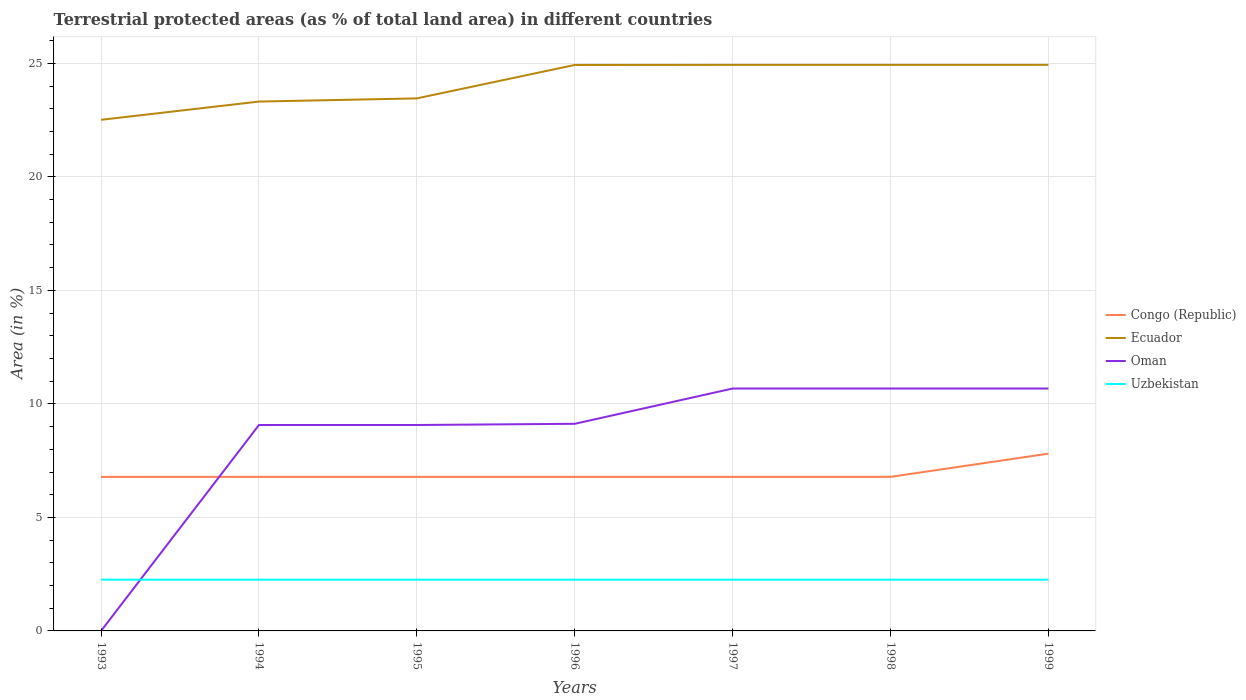How many different coloured lines are there?
Keep it short and to the point. 4. Is the number of lines equal to the number of legend labels?
Keep it short and to the point. Yes. Across all years, what is the maximum percentage of terrestrial protected land in Oman?
Provide a succinct answer. 0. What is the difference between the highest and the second highest percentage of terrestrial protected land in Oman?
Your answer should be very brief. 10.68. What is the difference between the highest and the lowest percentage of terrestrial protected land in Uzbekistan?
Keep it short and to the point. 7. Does the graph contain any zero values?
Offer a terse response. No. How many legend labels are there?
Offer a terse response. 4. What is the title of the graph?
Give a very brief answer. Terrestrial protected areas (as % of total land area) in different countries. What is the label or title of the Y-axis?
Provide a short and direct response. Area (in %). What is the Area (in %) in Congo (Republic) in 1993?
Your answer should be very brief. 6.79. What is the Area (in %) of Ecuador in 1993?
Your answer should be compact. 22.51. What is the Area (in %) of Oman in 1993?
Offer a very short reply. 0. What is the Area (in %) in Uzbekistan in 1993?
Offer a terse response. 2.26. What is the Area (in %) of Congo (Republic) in 1994?
Give a very brief answer. 6.79. What is the Area (in %) of Ecuador in 1994?
Provide a succinct answer. 23.32. What is the Area (in %) of Oman in 1994?
Provide a succinct answer. 9.07. What is the Area (in %) in Uzbekistan in 1994?
Offer a terse response. 2.26. What is the Area (in %) of Congo (Republic) in 1995?
Offer a terse response. 6.79. What is the Area (in %) of Ecuador in 1995?
Provide a succinct answer. 23.46. What is the Area (in %) in Oman in 1995?
Provide a short and direct response. 9.07. What is the Area (in %) in Uzbekistan in 1995?
Your response must be concise. 2.26. What is the Area (in %) of Congo (Republic) in 1996?
Ensure brevity in your answer.  6.79. What is the Area (in %) in Ecuador in 1996?
Your answer should be compact. 24.93. What is the Area (in %) in Oman in 1996?
Provide a short and direct response. 9.12. What is the Area (in %) of Uzbekistan in 1996?
Your response must be concise. 2.26. What is the Area (in %) in Congo (Republic) in 1997?
Offer a terse response. 6.79. What is the Area (in %) in Ecuador in 1997?
Provide a short and direct response. 24.93. What is the Area (in %) in Oman in 1997?
Provide a short and direct response. 10.68. What is the Area (in %) of Uzbekistan in 1997?
Your response must be concise. 2.26. What is the Area (in %) of Congo (Republic) in 1998?
Provide a succinct answer. 6.79. What is the Area (in %) in Ecuador in 1998?
Your answer should be very brief. 24.93. What is the Area (in %) in Oman in 1998?
Make the answer very short. 10.68. What is the Area (in %) of Uzbekistan in 1998?
Your response must be concise. 2.26. What is the Area (in %) in Congo (Republic) in 1999?
Make the answer very short. 7.81. What is the Area (in %) in Ecuador in 1999?
Ensure brevity in your answer.  24.93. What is the Area (in %) of Oman in 1999?
Make the answer very short. 10.68. What is the Area (in %) of Uzbekistan in 1999?
Make the answer very short. 2.26. Across all years, what is the maximum Area (in %) of Congo (Republic)?
Make the answer very short. 7.81. Across all years, what is the maximum Area (in %) in Ecuador?
Offer a very short reply. 24.93. Across all years, what is the maximum Area (in %) of Oman?
Provide a short and direct response. 10.68. Across all years, what is the maximum Area (in %) in Uzbekistan?
Ensure brevity in your answer.  2.26. Across all years, what is the minimum Area (in %) in Congo (Republic)?
Offer a terse response. 6.79. Across all years, what is the minimum Area (in %) of Ecuador?
Offer a very short reply. 22.51. Across all years, what is the minimum Area (in %) in Oman?
Your response must be concise. 0. Across all years, what is the minimum Area (in %) of Uzbekistan?
Provide a short and direct response. 2.26. What is the total Area (in %) of Congo (Republic) in the graph?
Your response must be concise. 48.53. What is the total Area (in %) in Ecuador in the graph?
Provide a short and direct response. 169.02. What is the total Area (in %) of Oman in the graph?
Your response must be concise. 59.3. What is the total Area (in %) in Uzbekistan in the graph?
Your response must be concise. 15.8. What is the difference between the Area (in %) of Congo (Republic) in 1993 and that in 1994?
Provide a short and direct response. -0. What is the difference between the Area (in %) of Ecuador in 1993 and that in 1994?
Provide a short and direct response. -0.8. What is the difference between the Area (in %) of Oman in 1993 and that in 1994?
Offer a very short reply. -9.07. What is the difference between the Area (in %) of Uzbekistan in 1993 and that in 1994?
Provide a succinct answer. 0. What is the difference between the Area (in %) of Congo (Republic) in 1993 and that in 1995?
Provide a succinct answer. -0. What is the difference between the Area (in %) in Ecuador in 1993 and that in 1995?
Provide a short and direct response. -0.94. What is the difference between the Area (in %) of Oman in 1993 and that in 1995?
Provide a succinct answer. -9.07. What is the difference between the Area (in %) of Congo (Republic) in 1993 and that in 1996?
Make the answer very short. -0. What is the difference between the Area (in %) of Ecuador in 1993 and that in 1996?
Provide a succinct answer. -2.42. What is the difference between the Area (in %) in Oman in 1993 and that in 1996?
Your answer should be very brief. -9.12. What is the difference between the Area (in %) of Uzbekistan in 1993 and that in 1996?
Ensure brevity in your answer.  0. What is the difference between the Area (in %) in Congo (Republic) in 1993 and that in 1997?
Your response must be concise. -0. What is the difference between the Area (in %) in Ecuador in 1993 and that in 1997?
Your response must be concise. -2.42. What is the difference between the Area (in %) in Oman in 1993 and that in 1997?
Keep it short and to the point. -10.68. What is the difference between the Area (in %) in Uzbekistan in 1993 and that in 1997?
Offer a very short reply. 0. What is the difference between the Area (in %) in Congo (Republic) in 1993 and that in 1998?
Keep it short and to the point. -0. What is the difference between the Area (in %) in Ecuador in 1993 and that in 1998?
Offer a very short reply. -2.42. What is the difference between the Area (in %) of Oman in 1993 and that in 1998?
Keep it short and to the point. -10.68. What is the difference between the Area (in %) in Congo (Republic) in 1993 and that in 1999?
Provide a short and direct response. -1.02. What is the difference between the Area (in %) of Ecuador in 1993 and that in 1999?
Your response must be concise. -2.42. What is the difference between the Area (in %) in Oman in 1993 and that in 1999?
Keep it short and to the point. -10.68. What is the difference between the Area (in %) in Uzbekistan in 1993 and that in 1999?
Your response must be concise. 0. What is the difference between the Area (in %) in Ecuador in 1994 and that in 1995?
Provide a short and direct response. -0.14. What is the difference between the Area (in %) in Oman in 1994 and that in 1995?
Provide a succinct answer. 0. What is the difference between the Area (in %) in Uzbekistan in 1994 and that in 1995?
Provide a succinct answer. 0. What is the difference between the Area (in %) in Ecuador in 1994 and that in 1996?
Offer a terse response. -1.61. What is the difference between the Area (in %) in Oman in 1994 and that in 1996?
Offer a terse response. -0.05. What is the difference between the Area (in %) in Uzbekistan in 1994 and that in 1996?
Keep it short and to the point. 0. What is the difference between the Area (in %) of Congo (Republic) in 1994 and that in 1997?
Make the answer very short. 0. What is the difference between the Area (in %) of Ecuador in 1994 and that in 1997?
Provide a succinct answer. -1.62. What is the difference between the Area (in %) in Oman in 1994 and that in 1997?
Make the answer very short. -1.61. What is the difference between the Area (in %) in Uzbekistan in 1994 and that in 1997?
Give a very brief answer. 0. What is the difference between the Area (in %) of Ecuador in 1994 and that in 1998?
Offer a very short reply. -1.62. What is the difference between the Area (in %) of Oman in 1994 and that in 1998?
Your response must be concise. -1.61. What is the difference between the Area (in %) in Congo (Republic) in 1994 and that in 1999?
Your answer should be compact. -1.02. What is the difference between the Area (in %) of Ecuador in 1994 and that in 1999?
Provide a short and direct response. -1.62. What is the difference between the Area (in %) in Oman in 1994 and that in 1999?
Your answer should be compact. -1.61. What is the difference between the Area (in %) of Uzbekistan in 1994 and that in 1999?
Offer a very short reply. 0. What is the difference between the Area (in %) of Ecuador in 1995 and that in 1996?
Make the answer very short. -1.47. What is the difference between the Area (in %) in Oman in 1995 and that in 1996?
Your answer should be very brief. -0.05. What is the difference between the Area (in %) in Uzbekistan in 1995 and that in 1996?
Offer a terse response. 0. What is the difference between the Area (in %) in Congo (Republic) in 1995 and that in 1997?
Give a very brief answer. 0. What is the difference between the Area (in %) in Ecuador in 1995 and that in 1997?
Offer a very short reply. -1.48. What is the difference between the Area (in %) in Oman in 1995 and that in 1997?
Provide a short and direct response. -1.61. What is the difference between the Area (in %) in Uzbekistan in 1995 and that in 1997?
Provide a succinct answer. 0. What is the difference between the Area (in %) in Ecuador in 1995 and that in 1998?
Offer a very short reply. -1.48. What is the difference between the Area (in %) of Oman in 1995 and that in 1998?
Your response must be concise. -1.61. What is the difference between the Area (in %) of Uzbekistan in 1995 and that in 1998?
Your response must be concise. 0. What is the difference between the Area (in %) of Congo (Republic) in 1995 and that in 1999?
Offer a very short reply. -1.02. What is the difference between the Area (in %) of Ecuador in 1995 and that in 1999?
Keep it short and to the point. -1.48. What is the difference between the Area (in %) in Oman in 1995 and that in 1999?
Offer a very short reply. -1.61. What is the difference between the Area (in %) in Congo (Republic) in 1996 and that in 1997?
Your answer should be compact. 0. What is the difference between the Area (in %) of Ecuador in 1996 and that in 1997?
Ensure brevity in your answer.  -0. What is the difference between the Area (in %) in Oman in 1996 and that in 1997?
Make the answer very short. -1.55. What is the difference between the Area (in %) of Congo (Republic) in 1996 and that in 1998?
Offer a very short reply. 0. What is the difference between the Area (in %) of Ecuador in 1996 and that in 1998?
Your answer should be very brief. -0. What is the difference between the Area (in %) of Oman in 1996 and that in 1998?
Provide a succinct answer. -1.55. What is the difference between the Area (in %) of Uzbekistan in 1996 and that in 1998?
Your answer should be very brief. 0. What is the difference between the Area (in %) of Congo (Republic) in 1996 and that in 1999?
Ensure brevity in your answer.  -1.02. What is the difference between the Area (in %) of Ecuador in 1996 and that in 1999?
Give a very brief answer. -0. What is the difference between the Area (in %) in Oman in 1996 and that in 1999?
Your answer should be very brief. -1.55. What is the difference between the Area (in %) in Ecuador in 1997 and that in 1998?
Your answer should be very brief. 0. What is the difference between the Area (in %) in Uzbekistan in 1997 and that in 1998?
Ensure brevity in your answer.  0. What is the difference between the Area (in %) in Congo (Republic) in 1997 and that in 1999?
Your response must be concise. -1.02. What is the difference between the Area (in %) in Oman in 1997 and that in 1999?
Make the answer very short. 0. What is the difference between the Area (in %) of Congo (Republic) in 1998 and that in 1999?
Keep it short and to the point. -1.02. What is the difference between the Area (in %) of Uzbekistan in 1998 and that in 1999?
Ensure brevity in your answer.  0. What is the difference between the Area (in %) in Congo (Republic) in 1993 and the Area (in %) in Ecuador in 1994?
Provide a short and direct response. -16.53. What is the difference between the Area (in %) of Congo (Republic) in 1993 and the Area (in %) of Oman in 1994?
Make the answer very short. -2.28. What is the difference between the Area (in %) in Congo (Republic) in 1993 and the Area (in %) in Uzbekistan in 1994?
Ensure brevity in your answer.  4.53. What is the difference between the Area (in %) in Ecuador in 1993 and the Area (in %) in Oman in 1994?
Ensure brevity in your answer.  13.44. What is the difference between the Area (in %) in Ecuador in 1993 and the Area (in %) in Uzbekistan in 1994?
Provide a succinct answer. 20.26. What is the difference between the Area (in %) of Oman in 1993 and the Area (in %) of Uzbekistan in 1994?
Provide a succinct answer. -2.26. What is the difference between the Area (in %) in Congo (Republic) in 1993 and the Area (in %) in Ecuador in 1995?
Give a very brief answer. -16.67. What is the difference between the Area (in %) in Congo (Republic) in 1993 and the Area (in %) in Oman in 1995?
Your answer should be very brief. -2.28. What is the difference between the Area (in %) in Congo (Republic) in 1993 and the Area (in %) in Uzbekistan in 1995?
Your response must be concise. 4.53. What is the difference between the Area (in %) of Ecuador in 1993 and the Area (in %) of Oman in 1995?
Offer a terse response. 13.44. What is the difference between the Area (in %) of Ecuador in 1993 and the Area (in %) of Uzbekistan in 1995?
Make the answer very short. 20.26. What is the difference between the Area (in %) of Oman in 1993 and the Area (in %) of Uzbekistan in 1995?
Your answer should be compact. -2.26. What is the difference between the Area (in %) in Congo (Republic) in 1993 and the Area (in %) in Ecuador in 1996?
Offer a terse response. -18.14. What is the difference between the Area (in %) in Congo (Republic) in 1993 and the Area (in %) in Oman in 1996?
Ensure brevity in your answer.  -2.34. What is the difference between the Area (in %) of Congo (Republic) in 1993 and the Area (in %) of Uzbekistan in 1996?
Keep it short and to the point. 4.53. What is the difference between the Area (in %) of Ecuador in 1993 and the Area (in %) of Oman in 1996?
Keep it short and to the point. 13.39. What is the difference between the Area (in %) in Ecuador in 1993 and the Area (in %) in Uzbekistan in 1996?
Offer a terse response. 20.26. What is the difference between the Area (in %) of Oman in 1993 and the Area (in %) of Uzbekistan in 1996?
Your response must be concise. -2.26. What is the difference between the Area (in %) of Congo (Republic) in 1993 and the Area (in %) of Ecuador in 1997?
Give a very brief answer. -18.15. What is the difference between the Area (in %) of Congo (Republic) in 1993 and the Area (in %) of Oman in 1997?
Offer a terse response. -3.89. What is the difference between the Area (in %) in Congo (Republic) in 1993 and the Area (in %) in Uzbekistan in 1997?
Offer a terse response. 4.53. What is the difference between the Area (in %) in Ecuador in 1993 and the Area (in %) in Oman in 1997?
Provide a succinct answer. 11.84. What is the difference between the Area (in %) in Ecuador in 1993 and the Area (in %) in Uzbekistan in 1997?
Your answer should be compact. 20.26. What is the difference between the Area (in %) of Oman in 1993 and the Area (in %) of Uzbekistan in 1997?
Your response must be concise. -2.26. What is the difference between the Area (in %) of Congo (Republic) in 1993 and the Area (in %) of Ecuador in 1998?
Provide a short and direct response. -18.15. What is the difference between the Area (in %) in Congo (Republic) in 1993 and the Area (in %) in Oman in 1998?
Provide a short and direct response. -3.89. What is the difference between the Area (in %) of Congo (Republic) in 1993 and the Area (in %) of Uzbekistan in 1998?
Your answer should be compact. 4.53. What is the difference between the Area (in %) of Ecuador in 1993 and the Area (in %) of Oman in 1998?
Make the answer very short. 11.84. What is the difference between the Area (in %) of Ecuador in 1993 and the Area (in %) of Uzbekistan in 1998?
Provide a succinct answer. 20.26. What is the difference between the Area (in %) of Oman in 1993 and the Area (in %) of Uzbekistan in 1998?
Ensure brevity in your answer.  -2.26. What is the difference between the Area (in %) of Congo (Republic) in 1993 and the Area (in %) of Ecuador in 1999?
Ensure brevity in your answer.  -18.15. What is the difference between the Area (in %) in Congo (Republic) in 1993 and the Area (in %) in Oman in 1999?
Offer a very short reply. -3.89. What is the difference between the Area (in %) of Congo (Republic) in 1993 and the Area (in %) of Uzbekistan in 1999?
Give a very brief answer. 4.53. What is the difference between the Area (in %) of Ecuador in 1993 and the Area (in %) of Oman in 1999?
Your response must be concise. 11.84. What is the difference between the Area (in %) of Ecuador in 1993 and the Area (in %) of Uzbekistan in 1999?
Provide a succinct answer. 20.26. What is the difference between the Area (in %) in Oman in 1993 and the Area (in %) in Uzbekistan in 1999?
Your answer should be compact. -2.26. What is the difference between the Area (in %) of Congo (Republic) in 1994 and the Area (in %) of Ecuador in 1995?
Provide a short and direct response. -16.67. What is the difference between the Area (in %) of Congo (Republic) in 1994 and the Area (in %) of Oman in 1995?
Your response must be concise. -2.28. What is the difference between the Area (in %) of Congo (Republic) in 1994 and the Area (in %) of Uzbekistan in 1995?
Provide a short and direct response. 4.53. What is the difference between the Area (in %) in Ecuador in 1994 and the Area (in %) in Oman in 1995?
Ensure brevity in your answer.  14.25. What is the difference between the Area (in %) of Ecuador in 1994 and the Area (in %) of Uzbekistan in 1995?
Provide a succinct answer. 21.06. What is the difference between the Area (in %) of Oman in 1994 and the Area (in %) of Uzbekistan in 1995?
Your answer should be compact. 6.81. What is the difference between the Area (in %) of Congo (Republic) in 1994 and the Area (in %) of Ecuador in 1996?
Ensure brevity in your answer.  -18.14. What is the difference between the Area (in %) of Congo (Republic) in 1994 and the Area (in %) of Oman in 1996?
Provide a short and direct response. -2.34. What is the difference between the Area (in %) in Congo (Republic) in 1994 and the Area (in %) in Uzbekistan in 1996?
Provide a short and direct response. 4.53. What is the difference between the Area (in %) in Ecuador in 1994 and the Area (in %) in Oman in 1996?
Your answer should be compact. 14.19. What is the difference between the Area (in %) in Ecuador in 1994 and the Area (in %) in Uzbekistan in 1996?
Keep it short and to the point. 21.06. What is the difference between the Area (in %) of Oman in 1994 and the Area (in %) of Uzbekistan in 1996?
Offer a terse response. 6.81. What is the difference between the Area (in %) in Congo (Republic) in 1994 and the Area (in %) in Ecuador in 1997?
Provide a short and direct response. -18.15. What is the difference between the Area (in %) in Congo (Republic) in 1994 and the Area (in %) in Oman in 1997?
Provide a succinct answer. -3.89. What is the difference between the Area (in %) of Congo (Republic) in 1994 and the Area (in %) of Uzbekistan in 1997?
Your answer should be very brief. 4.53. What is the difference between the Area (in %) in Ecuador in 1994 and the Area (in %) in Oman in 1997?
Ensure brevity in your answer.  12.64. What is the difference between the Area (in %) in Ecuador in 1994 and the Area (in %) in Uzbekistan in 1997?
Your answer should be very brief. 21.06. What is the difference between the Area (in %) of Oman in 1994 and the Area (in %) of Uzbekistan in 1997?
Provide a succinct answer. 6.81. What is the difference between the Area (in %) in Congo (Republic) in 1994 and the Area (in %) in Ecuador in 1998?
Give a very brief answer. -18.15. What is the difference between the Area (in %) of Congo (Republic) in 1994 and the Area (in %) of Oman in 1998?
Your response must be concise. -3.89. What is the difference between the Area (in %) of Congo (Republic) in 1994 and the Area (in %) of Uzbekistan in 1998?
Give a very brief answer. 4.53. What is the difference between the Area (in %) of Ecuador in 1994 and the Area (in %) of Oman in 1998?
Keep it short and to the point. 12.64. What is the difference between the Area (in %) of Ecuador in 1994 and the Area (in %) of Uzbekistan in 1998?
Make the answer very short. 21.06. What is the difference between the Area (in %) in Oman in 1994 and the Area (in %) in Uzbekistan in 1998?
Provide a succinct answer. 6.81. What is the difference between the Area (in %) of Congo (Republic) in 1994 and the Area (in %) of Ecuador in 1999?
Provide a short and direct response. -18.15. What is the difference between the Area (in %) in Congo (Republic) in 1994 and the Area (in %) in Oman in 1999?
Offer a very short reply. -3.89. What is the difference between the Area (in %) in Congo (Republic) in 1994 and the Area (in %) in Uzbekistan in 1999?
Provide a short and direct response. 4.53. What is the difference between the Area (in %) of Ecuador in 1994 and the Area (in %) of Oman in 1999?
Ensure brevity in your answer.  12.64. What is the difference between the Area (in %) in Ecuador in 1994 and the Area (in %) in Uzbekistan in 1999?
Offer a terse response. 21.06. What is the difference between the Area (in %) in Oman in 1994 and the Area (in %) in Uzbekistan in 1999?
Ensure brevity in your answer.  6.81. What is the difference between the Area (in %) of Congo (Republic) in 1995 and the Area (in %) of Ecuador in 1996?
Provide a short and direct response. -18.14. What is the difference between the Area (in %) in Congo (Republic) in 1995 and the Area (in %) in Oman in 1996?
Ensure brevity in your answer.  -2.34. What is the difference between the Area (in %) of Congo (Republic) in 1995 and the Area (in %) of Uzbekistan in 1996?
Offer a terse response. 4.53. What is the difference between the Area (in %) in Ecuador in 1995 and the Area (in %) in Oman in 1996?
Ensure brevity in your answer.  14.33. What is the difference between the Area (in %) in Ecuador in 1995 and the Area (in %) in Uzbekistan in 1996?
Ensure brevity in your answer.  21.2. What is the difference between the Area (in %) of Oman in 1995 and the Area (in %) of Uzbekistan in 1996?
Provide a short and direct response. 6.81. What is the difference between the Area (in %) of Congo (Republic) in 1995 and the Area (in %) of Ecuador in 1997?
Provide a short and direct response. -18.15. What is the difference between the Area (in %) of Congo (Republic) in 1995 and the Area (in %) of Oman in 1997?
Ensure brevity in your answer.  -3.89. What is the difference between the Area (in %) in Congo (Republic) in 1995 and the Area (in %) in Uzbekistan in 1997?
Your response must be concise. 4.53. What is the difference between the Area (in %) in Ecuador in 1995 and the Area (in %) in Oman in 1997?
Your answer should be compact. 12.78. What is the difference between the Area (in %) of Ecuador in 1995 and the Area (in %) of Uzbekistan in 1997?
Provide a succinct answer. 21.2. What is the difference between the Area (in %) of Oman in 1995 and the Area (in %) of Uzbekistan in 1997?
Provide a succinct answer. 6.81. What is the difference between the Area (in %) in Congo (Republic) in 1995 and the Area (in %) in Ecuador in 1998?
Your response must be concise. -18.15. What is the difference between the Area (in %) of Congo (Republic) in 1995 and the Area (in %) of Oman in 1998?
Provide a succinct answer. -3.89. What is the difference between the Area (in %) of Congo (Republic) in 1995 and the Area (in %) of Uzbekistan in 1998?
Provide a succinct answer. 4.53. What is the difference between the Area (in %) in Ecuador in 1995 and the Area (in %) in Oman in 1998?
Ensure brevity in your answer.  12.78. What is the difference between the Area (in %) of Ecuador in 1995 and the Area (in %) of Uzbekistan in 1998?
Offer a very short reply. 21.2. What is the difference between the Area (in %) of Oman in 1995 and the Area (in %) of Uzbekistan in 1998?
Offer a very short reply. 6.81. What is the difference between the Area (in %) of Congo (Republic) in 1995 and the Area (in %) of Ecuador in 1999?
Offer a terse response. -18.15. What is the difference between the Area (in %) of Congo (Republic) in 1995 and the Area (in %) of Oman in 1999?
Your response must be concise. -3.89. What is the difference between the Area (in %) of Congo (Republic) in 1995 and the Area (in %) of Uzbekistan in 1999?
Your answer should be compact. 4.53. What is the difference between the Area (in %) of Ecuador in 1995 and the Area (in %) of Oman in 1999?
Keep it short and to the point. 12.78. What is the difference between the Area (in %) in Ecuador in 1995 and the Area (in %) in Uzbekistan in 1999?
Your response must be concise. 21.2. What is the difference between the Area (in %) in Oman in 1995 and the Area (in %) in Uzbekistan in 1999?
Keep it short and to the point. 6.81. What is the difference between the Area (in %) of Congo (Republic) in 1996 and the Area (in %) of Ecuador in 1997?
Offer a terse response. -18.15. What is the difference between the Area (in %) in Congo (Republic) in 1996 and the Area (in %) in Oman in 1997?
Your answer should be very brief. -3.89. What is the difference between the Area (in %) in Congo (Republic) in 1996 and the Area (in %) in Uzbekistan in 1997?
Keep it short and to the point. 4.53. What is the difference between the Area (in %) in Ecuador in 1996 and the Area (in %) in Oman in 1997?
Offer a terse response. 14.25. What is the difference between the Area (in %) of Ecuador in 1996 and the Area (in %) of Uzbekistan in 1997?
Make the answer very short. 22.67. What is the difference between the Area (in %) in Oman in 1996 and the Area (in %) in Uzbekistan in 1997?
Keep it short and to the point. 6.87. What is the difference between the Area (in %) in Congo (Republic) in 1996 and the Area (in %) in Ecuador in 1998?
Your answer should be very brief. -18.15. What is the difference between the Area (in %) of Congo (Republic) in 1996 and the Area (in %) of Oman in 1998?
Your answer should be compact. -3.89. What is the difference between the Area (in %) in Congo (Republic) in 1996 and the Area (in %) in Uzbekistan in 1998?
Your answer should be compact. 4.53. What is the difference between the Area (in %) in Ecuador in 1996 and the Area (in %) in Oman in 1998?
Provide a succinct answer. 14.25. What is the difference between the Area (in %) in Ecuador in 1996 and the Area (in %) in Uzbekistan in 1998?
Provide a succinct answer. 22.67. What is the difference between the Area (in %) of Oman in 1996 and the Area (in %) of Uzbekistan in 1998?
Ensure brevity in your answer.  6.87. What is the difference between the Area (in %) in Congo (Republic) in 1996 and the Area (in %) in Ecuador in 1999?
Keep it short and to the point. -18.15. What is the difference between the Area (in %) in Congo (Republic) in 1996 and the Area (in %) in Oman in 1999?
Give a very brief answer. -3.89. What is the difference between the Area (in %) in Congo (Republic) in 1996 and the Area (in %) in Uzbekistan in 1999?
Offer a very short reply. 4.53. What is the difference between the Area (in %) in Ecuador in 1996 and the Area (in %) in Oman in 1999?
Offer a terse response. 14.25. What is the difference between the Area (in %) in Ecuador in 1996 and the Area (in %) in Uzbekistan in 1999?
Provide a succinct answer. 22.67. What is the difference between the Area (in %) in Oman in 1996 and the Area (in %) in Uzbekistan in 1999?
Offer a terse response. 6.87. What is the difference between the Area (in %) in Congo (Republic) in 1997 and the Area (in %) in Ecuador in 1998?
Provide a short and direct response. -18.15. What is the difference between the Area (in %) in Congo (Republic) in 1997 and the Area (in %) in Oman in 1998?
Give a very brief answer. -3.89. What is the difference between the Area (in %) of Congo (Republic) in 1997 and the Area (in %) of Uzbekistan in 1998?
Give a very brief answer. 4.53. What is the difference between the Area (in %) of Ecuador in 1997 and the Area (in %) of Oman in 1998?
Keep it short and to the point. 14.26. What is the difference between the Area (in %) of Ecuador in 1997 and the Area (in %) of Uzbekistan in 1998?
Keep it short and to the point. 22.68. What is the difference between the Area (in %) of Oman in 1997 and the Area (in %) of Uzbekistan in 1998?
Your answer should be very brief. 8.42. What is the difference between the Area (in %) of Congo (Republic) in 1997 and the Area (in %) of Ecuador in 1999?
Offer a very short reply. -18.15. What is the difference between the Area (in %) of Congo (Republic) in 1997 and the Area (in %) of Oman in 1999?
Provide a succinct answer. -3.89. What is the difference between the Area (in %) of Congo (Republic) in 1997 and the Area (in %) of Uzbekistan in 1999?
Your answer should be very brief. 4.53. What is the difference between the Area (in %) in Ecuador in 1997 and the Area (in %) in Oman in 1999?
Make the answer very short. 14.26. What is the difference between the Area (in %) of Ecuador in 1997 and the Area (in %) of Uzbekistan in 1999?
Your answer should be compact. 22.68. What is the difference between the Area (in %) of Oman in 1997 and the Area (in %) of Uzbekistan in 1999?
Offer a terse response. 8.42. What is the difference between the Area (in %) of Congo (Republic) in 1998 and the Area (in %) of Ecuador in 1999?
Give a very brief answer. -18.15. What is the difference between the Area (in %) of Congo (Republic) in 1998 and the Area (in %) of Oman in 1999?
Your answer should be very brief. -3.89. What is the difference between the Area (in %) of Congo (Republic) in 1998 and the Area (in %) of Uzbekistan in 1999?
Offer a terse response. 4.53. What is the difference between the Area (in %) of Ecuador in 1998 and the Area (in %) of Oman in 1999?
Your answer should be very brief. 14.26. What is the difference between the Area (in %) in Ecuador in 1998 and the Area (in %) in Uzbekistan in 1999?
Your answer should be very brief. 22.68. What is the difference between the Area (in %) in Oman in 1998 and the Area (in %) in Uzbekistan in 1999?
Provide a succinct answer. 8.42. What is the average Area (in %) of Congo (Republic) per year?
Give a very brief answer. 6.93. What is the average Area (in %) of Ecuador per year?
Provide a short and direct response. 24.15. What is the average Area (in %) in Oman per year?
Provide a short and direct response. 8.47. What is the average Area (in %) of Uzbekistan per year?
Make the answer very short. 2.26. In the year 1993, what is the difference between the Area (in %) in Congo (Republic) and Area (in %) in Ecuador?
Your answer should be very brief. -15.73. In the year 1993, what is the difference between the Area (in %) of Congo (Republic) and Area (in %) of Oman?
Keep it short and to the point. 6.78. In the year 1993, what is the difference between the Area (in %) in Congo (Republic) and Area (in %) in Uzbekistan?
Make the answer very short. 4.53. In the year 1993, what is the difference between the Area (in %) in Ecuador and Area (in %) in Oman?
Your answer should be compact. 22.51. In the year 1993, what is the difference between the Area (in %) of Ecuador and Area (in %) of Uzbekistan?
Ensure brevity in your answer.  20.26. In the year 1993, what is the difference between the Area (in %) of Oman and Area (in %) of Uzbekistan?
Provide a short and direct response. -2.26. In the year 1994, what is the difference between the Area (in %) in Congo (Republic) and Area (in %) in Ecuador?
Your answer should be compact. -16.53. In the year 1994, what is the difference between the Area (in %) of Congo (Republic) and Area (in %) of Oman?
Ensure brevity in your answer.  -2.28. In the year 1994, what is the difference between the Area (in %) in Congo (Republic) and Area (in %) in Uzbekistan?
Offer a very short reply. 4.53. In the year 1994, what is the difference between the Area (in %) of Ecuador and Area (in %) of Oman?
Keep it short and to the point. 14.25. In the year 1994, what is the difference between the Area (in %) of Ecuador and Area (in %) of Uzbekistan?
Make the answer very short. 21.06. In the year 1994, what is the difference between the Area (in %) of Oman and Area (in %) of Uzbekistan?
Give a very brief answer. 6.81. In the year 1995, what is the difference between the Area (in %) in Congo (Republic) and Area (in %) in Ecuador?
Offer a very short reply. -16.67. In the year 1995, what is the difference between the Area (in %) in Congo (Republic) and Area (in %) in Oman?
Your response must be concise. -2.28. In the year 1995, what is the difference between the Area (in %) in Congo (Republic) and Area (in %) in Uzbekistan?
Your response must be concise. 4.53. In the year 1995, what is the difference between the Area (in %) in Ecuador and Area (in %) in Oman?
Give a very brief answer. 14.39. In the year 1995, what is the difference between the Area (in %) of Ecuador and Area (in %) of Uzbekistan?
Offer a very short reply. 21.2. In the year 1995, what is the difference between the Area (in %) in Oman and Area (in %) in Uzbekistan?
Your answer should be very brief. 6.81. In the year 1996, what is the difference between the Area (in %) in Congo (Republic) and Area (in %) in Ecuador?
Offer a terse response. -18.14. In the year 1996, what is the difference between the Area (in %) in Congo (Republic) and Area (in %) in Oman?
Give a very brief answer. -2.34. In the year 1996, what is the difference between the Area (in %) of Congo (Republic) and Area (in %) of Uzbekistan?
Your response must be concise. 4.53. In the year 1996, what is the difference between the Area (in %) in Ecuador and Area (in %) in Oman?
Ensure brevity in your answer.  15.81. In the year 1996, what is the difference between the Area (in %) of Ecuador and Area (in %) of Uzbekistan?
Provide a short and direct response. 22.67. In the year 1996, what is the difference between the Area (in %) in Oman and Area (in %) in Uzbekistan?
Give a very brief answer. 6.87. In the year 1997, what is the difference between the Area (in %) in Congo (Republic) and Area (in %) in Ecuador?
Your answer should be compact. -18.15. In the year 1997, what is the difference between the Area (in %) in Congo (Republic) and Area (in %) in Oman?
Give a very brief answer. -3.89. In the year 1997, what is the difference between the Area (in %) in Congo (Republic) and Area (in %) in Uzbekistan?
Make the answer very short. 4.53. In the year 1997, what is the difference between the Area (in %) in Ecuador and Area (in %) in Oman?
Provide a short and direct response. 14.26. In the year 1997, what is the difference between the Area (in %) in Ecuador and Area (in %) in Uzbekistan?
Make the answer very short. 22.68. In the year 1997, what is the difference between the Area (in %) in Oman and Area (in %) in Uzbekistan?
Your answer should be very brief. 8.42. In the year 1998, what is the difference between the Area (in %) of Congo (Republic) and Area (in %) of Ecuador?
Your answer should be compact. -18.15. In the year 1998, what is the difference between the Area (in %) of Congo (Republic) and Area (in %) of Oman?
Offer a terse response. -3.89. In the year 1998, what is the difference between the Area (in %) of Congo (Republic) and Area (in %) of Uzbekistan?
Your answer should be very brief. 4.53. In the year 1998, what is the difference between the Area (in %) of Ecuador and Area (in %) of Oman?
Provide a succinct answer. 14.26. In the year 1998, what is the difference between the Area (in %) in Ecuador and Area (in %) in Uzbekistan?
Offer a terse response. 22.68. In the year 1998, what is the difference between the Area (in %) in Oman and Area (in %) in Uzbekistan?
Provide a succinct answer. 8.42. In the year 1999, what is the difference between the Area (in %) in Congo (Republic) and Area (in %) in Ecuador?
Keep it short and to the point. -17.13. In the year 1999, what is the difference between the Area (in %) in Congo (Republic) and Area (in %) in Oman?
Your answer should be compact. -2.87. In the year 1999, what is the difference between the Area (in %) of Congo (Republic) and Area (in %) of Uzbekistan?
Provide a succinct answer. 5.55. In the year 1999, what is the difference between the Area (in %) in Ecuador and Area (in %) in Oman?
Give a very brief answer. 14.26. In the year 1999, what is the difference between the Area (in %) of Ecuador and Area (in %) of Uzbekistan?
Your answer should be compact. 22.68. In the year 1999, what is the difference between the Area (in %) in Oman and Area (in %) in Uzbekistan?
Provide a short and direct response. 8.42. What is the ratio of the Area (in %) of Congo (Republic) in 1993 to that in 1994?
Give a very brief answer. 1. What is the ratio of the Area (in %) in Ecuador in 1993 to that in 1994?
Ensure brevity in your answer.  0.97. What is the ratio of the Area (in %) in Oman in 1993 to that in 1994?
Provide a succinct answer. 0. What is the ratio of the Area (in %) in Uzbekistan in 1993 to that in 1994?
Ensure brevity in your answer.  1. What is the ratio of the Area (in %) of Congo (Republic) in 1993 to that in 1995?
Your answer should be compact. 1. What is the ratio of the Area (in %) of Ecuador in 1993 to that in 1995?
Give a very brief answer. 0.96. What is the ratio of the Area (in %) of Uzbekistan in 1993 to that in 1995?
Your answer should be very brief. 1. What is the ratio of the Area (in %) in Ecuador in 1993 to that in 1996?
Offer a terse response. 0.9. What is the ratio of the Area (in %) in Uzbekistan in 1993 to that in 1996?
Your response must be concise. 1. What is the ratio of the Area (in %) of Ecuador in 1993 to that in 1997?
Your answer should be very brief. 0.9. What is the ratio of the Area (in %) of Uzbekistan in 1993 to that in 1997?
Your answer should be compact. 1. What is the ratio of the Area (in %) of Congo (Republic) in 1993 to that in 1998?
Offer a terse response. 1. What is the ratio of the Area (in %) of Ecuador in 1993 to that in 1998?
Your answer should be compact. 0.9. What is the ratio of the Area (in %) of Oman in 1993 to that in 1998?
Provide a succinct answer. 0. What is the ratio of the Area (in %) in Uzbekistan in 1993 to that in 1998?
Your answer should be very brief. 1. What is the ratio of the Area (in %) of Congo (Republic) in 1993 to that in 1999?
Give a very brief answer. 0.87. What is the ratio of the Area (in %) of Ecuador in 1993 to that in 1999?
Provide a succinct answer. 0.9. What is the ratio of the Area (in %) in Uzbekistan in 1993 to that in 1999?
Offer a very short reply. 1. What is the ratio of the Area (in %) of Congo (Republic) in 1994 to that in 1995?
Your answer should be compact. 1. What is the ratio of the Area (in %) of Ecuador in 1994 to that in 1995?
Your answer should be compact. 0.99. What is the ratio of the Area (in %) of Uzbekistan in 1994 to that in 1995?
Keep it short and to the point. 1. What is the ratio of the Area (in %) in Ecuador in 1994 to that in 1996?
Your response must be concise. 0.94. What is the ratio of the Area (in %) in Uzbekistan in 1994 to that in 1996?
Make the answer very short. 1. What is the ratio of the Area (in %) in Congo (Republic) in 1994 to that in 1997?
Your answer should be compact. 1. What is the ratio of the Area (in %) in Ecuador in 1994 to that in 1997?
Your response must be concise. 0.94. What is the ratio of the Area (in %) in Oman in 1994 to that in 1997?
Your answer should be very brief. 0.85. What is the ratio of the Area (in %) in Uzbekistan in 1994 to that in 1997?
Provide a short and direct response. 1. What is the ratio of the Area (in %) of Ecuador in 1994 to that in 1998?
Your response must be concise. 0.94. What is the ratio of the Area (in %) of Oman in 1994 to that in 1998?
Provide a short and direct response. 0.85. What is the ratio of the Area (in %) in Congo (Republic) in 1994 to that in 1999?
Provide a short and direct response. 0.87. What is the ratio of the Area (in %) in Ecuador in 1994 to that in 1999?
Your answer should be compact. 0.94. What is the ratio of the Area (in %) in Oman in 1994 to that in 1999?
Ensure brevity in your answer.  0.85. What is the ratio of the Area (in %) of Uzbekistan in 1994 to that in 1999?
Keep it short and to the point. 1. What is the ratio of the Area (in %) of Ecuador in 1995 to that in 1996?
Provide a succinct answer. 0.94. What is the ratio of the Area (in %) of Oman in 1995 to that in 1996?
Your answer should be very brief. 0.99. What is the ratio of the Area (in %) of Uzbekistan in 1995 to that in 1996?
Give a very brief answer. 1. What is the ratio of the Area (in %) of Congo (Republic) in 1995 to that in 1997?
Provide a succinct answer. 1. What is the ratio of the Area (in %) in Ecuador in 1995 to that in 1997?
Your response must be concise. 0.94. What is the ratio of the Area (in %) of Oman in 1995 to that in 1997?
Offer a very short reply. 0.85. What is the ratio of the Area (in %) of Ecuador in 1995 to that in 1998?
Make the answer very short. 0.94. What is the ratio of the Area (in %) in Oman in 1995 to that in 1998?
Give a very brief answer. 0.85. What is the ratio of the Area (in %) in Uzbekistan in 1995 to that in 1998?
Give a very brief answer. 1. What is the ratio of the Area (in %) of Congo (Republic) in 1995 to that in 1999?
Ensure brevity in your answer.  0.87. What is the ratio of the Area (in %) in Ecuador in 1995 to that in 1999?
Provide a succinct answer. 0.94. What is the ratio of the Area (in %) of Oman in 1995 to that in 1999?
Your answer should be very brief. 0.85. What is the ratio of the Area (in %) of Uzbekistan in 1995 to that in 1999?
Your answer should be compact. 1. What is the ratio of the Area (in %) in Ecuador in 1996 to that in 1997?
Provide a succinct answer. 1. What is the ratio of the Area (in %) in Oman in 1996 to that in 1997?
Keep it short and to the point. 0.85. What is the ratio of the Area (in %) in Oman in 1996 to that in 1998?
Offer a terse response. 0.85. What is the ratio of the Area (in %) in Congo (Republic) in 1996 to that in 1999?
Your answer should be compact. 0.87. What is the ratio of the Area (in %) in Oman in 1996 to that in 1999?
Provide a short and direct response. 0.85. What is the ratio of the Area (in %) in Uzbekistan in 1996 to that in 1999?
Offer a terse response. 1. What is the ratio of the Area (in %) in Ecuador in 1997 to that in 1998?
Keep it short and to the point. 1. What is the ratio of the Area (in %) in Uzbekistan in 1997 to that in 1998?
Provide a short and direct response. 1. What is the ratio of the Area (in %) of Congo (Republic) in 1997 to that in 1999?
Your answer should be compact. 0.87. What is the ratio of the Area (in %) of Ecuador in 1997 to that in 1999?
Provide a short and direct response. 1. What is the ratio of the Area (in %) in Oman in 1997 to that in 1999?
Offer a very short reply. 1. What is the ratio of the Area (in %) of Uzbekistan in 1997 to that in 1999?
Offer a terse response. 1. What is the ratio of the Area (in %) of Congo (Republic) in 1998 to that in 1999?
Your answer should be compact. 0.87. What is the ratio of the Area (in %) in Ecuador in 1998 to that in 1999?
Ensure brevity in your answer.  1. What is the ratio of the Area (in %) in Oman in 1998 to that in 1999?
Give a very brief answer. 1. What is the ratio of the Area (in %) in Uzbekistan in 1998 to that in 1999?
Offer a very short reply. 1. What is the difference between the highest and the second highest Area (in %) of Congo (Republic)?
Keep it short and to the point. 1.02. What is the difference between the highest and the second highest Area (in %) in Ecuador?
Give a very brief answer. 0. What is the difference between the highest and the second highest Area (in %) of Oman?
Offer a terse response. 0. What is the difference between the highest and the second highest Area (in %) of Uzbekistan?
Ensure brevity in your answer.  0. What is the difference between the highest and the lowest Area (in %) of Congo (Republic)?
Provide a succinct answer. 1.02. What is the difference between the highest and the lowest Area (in %) of Ecuador?
Offer a very short reply. 2.42. What is the difference between the highest and the lowest Area (in %) of Oman?
Keep it short and to the point. 10.68. What is the difference between the highest and the lowest Area (in %) in Uzbekistan?
Make the answer very short. 0. 